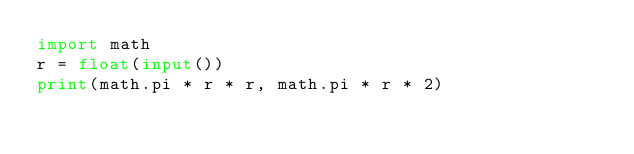Convert code to text. <code><loc_0><loc_0><loc_500><loc_500><_Python_>import math
r = float(input())
print(math.pi * r * r, math.pi * r * 2)
</code> 